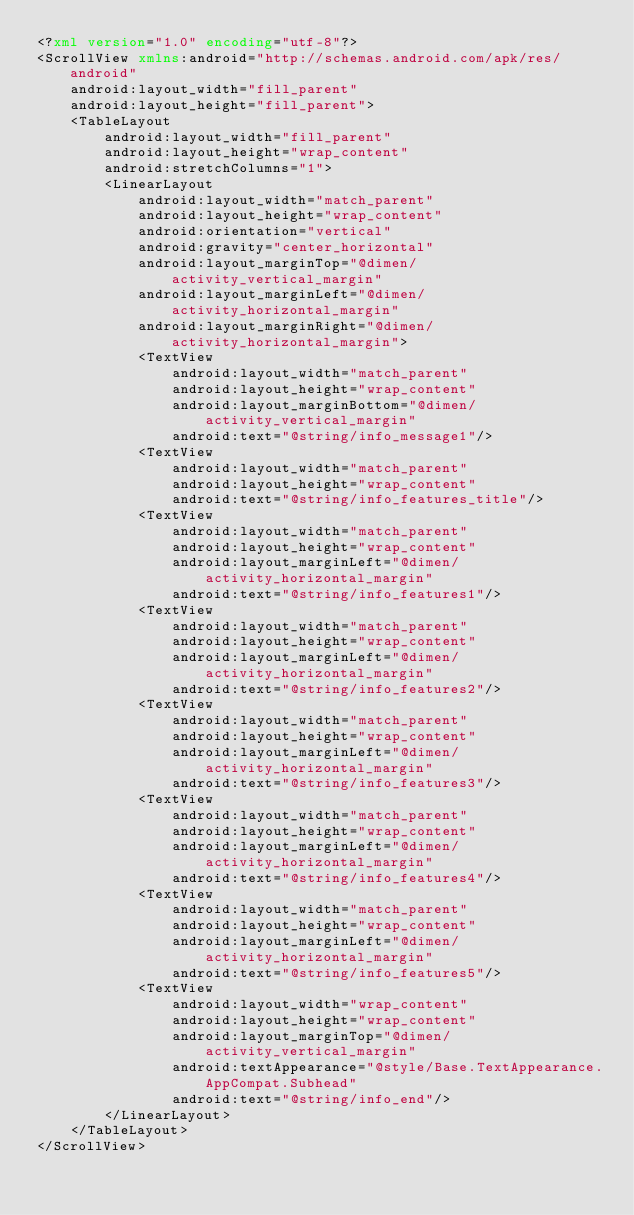<code> <loc_0><loc_0><loc_500><loc_500><_XML_><?xml version="1.0" encoding="utf-8"?>
<ScrollView xmlns:android="http://schemas.android.com/apk/res/android"
    android:layout_width="fill_parent"
    android:layout_height="fill_parent">
    <TableLayout
        android:layout_width="fill_parent"
        android:layout_height="wrap_content"
        android:stretchColumns="1">
        <LinearLayout
            android:layout_width="match_parent"
            android:layout_height="wrap_content"
            android:orientation="vertical"
            android:gravity="center_horizontal"
            android:layout_marginTop="@dimen/activity_vertical_margin"
            android:layout_marginLeft="@dimen/activity_horizontal_margin"
            android:layout_marginRight="@dimen/activity_horizontal_margin">
            <TextView
                android:layout_width="match_parent"
                android:layout_height="wrap_content"
                android:layout_marginBottom="@dimen/activity_vertical_margin"
                android:text="@string/info_message1"/>
            <TextView
                android:layout_width="match_parent"
                android:layout_height="wrap_content"
                android:text="@string/info_features_title"/>
            <TextView
                android:layout_width="match_parent"
                android:layout_height="wrap_content"
                android:layout_marginLeft="@dimen/activity_horizontal_margin"
                android:text="@string/info_features1"/>
            <TextView
                android:layout_width="match_parent"
                android:layout_height="wrap_content"
                android:layout_marginLeft="@dimen/activity_horizontal_margin"
                android:text="@string/info_features2"/>
            <TextView
                android:layout_width="match_parent"
                android:layout_height="wrap_content"
                android:layout_marginLeft="@dimen/activity_horizontal_margin"
                android:text="@string/info_features3"/>
            <TextView
                android:layout_width="match_parent"
                android:layout_height="wrap_content"
                android:layout_marginLeft="@dimen/activity_horizontal_margin"
                android:text="@string/info_features4"/>
            <TextView
                android:layout_width="match_parent"
                android:layout_height="wrap_content"
                android:layout_marginLeft="@dimen/activity_horizontal_margin"
                android:text="@string/info_features5"/>
            <TextView
                android:layout_width="wrap_content"
                android:layout_height="wrap_content"
                android:layout_marginTop="@dimen/activity_vertical_margin"
                android:textAppearance="@style/Base.TextAppearance.AppCompat.Subhead"
                android:text="@string/info_end"/>
        </LinearLayout>
    </TableLayout>
</ScrollView>
</code> 